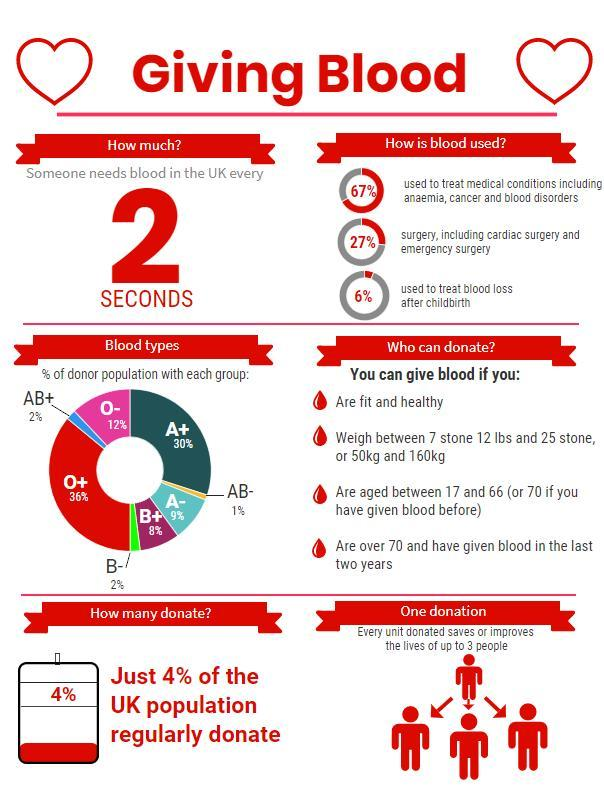What percentage of UK donor population do not donate blood regularly?
Answer the question with a short phrase. 96% What is the percentage of donor population with O+ blood group in UK? 36% Which blood group type has the highest percentage of donor population in UK? O+ What is the percentage of donor population with O- blood group in UK? 12% Which blood group type has the  second least percentage of donor population in UK? AB+, B- Which blood group type has the least percentage of donor population in UK? AB- What is the percentage of donor population with A+ blood group in UK? 30% 